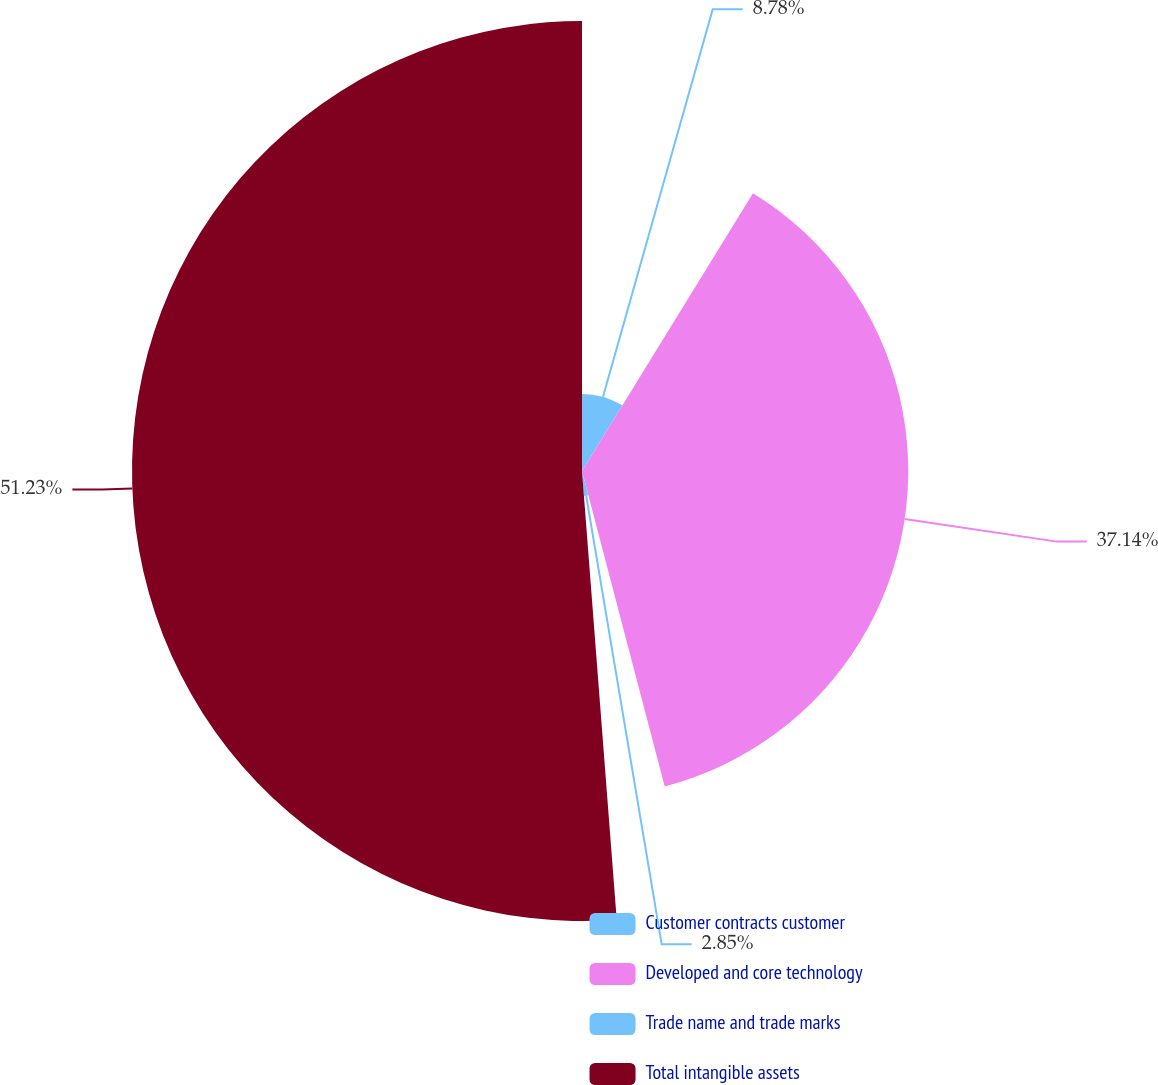Convert chart. <chart><loc_0><loc_0><loc_500><loc_500><pie_chart><fcel>Customer contracts customer<fcel>Developed and core technology<fcel>Trade name and trade marks<fcel>Total intangible assets<nl><fcel>8.78%<fcel>37.14%<fcel>2.85%<fcel>51.23%<nl></chart> 